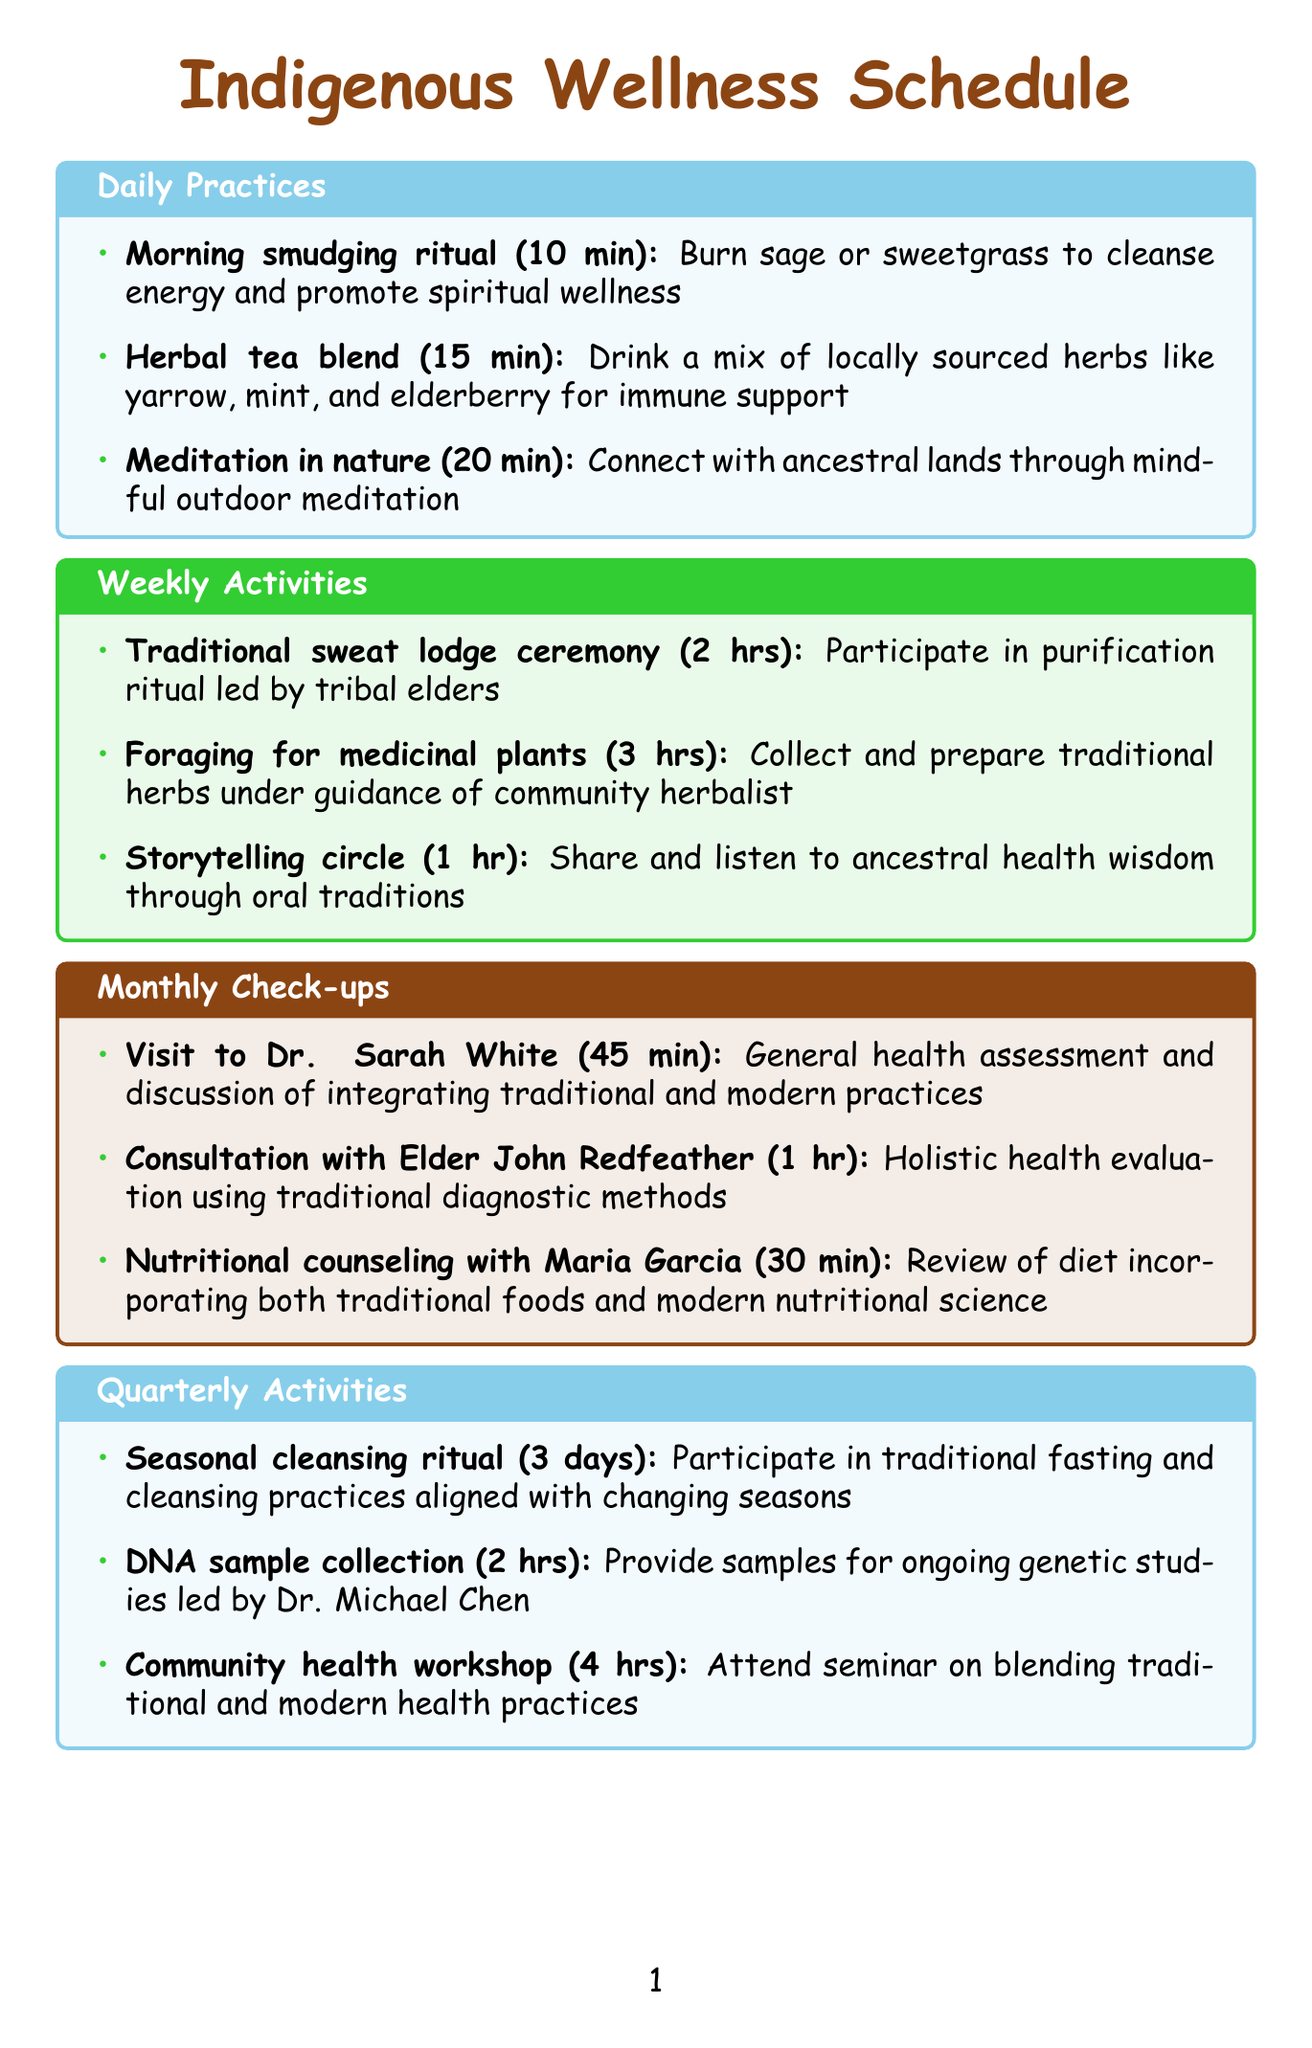What is the duration of the morning smudging ritual? The duration of the morning smudging ritual, as stated in the document, is 10 minutes.
Answer: 10 minutes Who leads the traditional sweat lodge ceremony? The document indicates that the traditional sweat lodge ceremony is led by tribal elders.
Answer: Tribal elders How long is the consultation with Elder John Redfeather? The document specifies that the consultation with Elder John Redfeather lasts for 1 hour.
Answer: 1 hour What is the primary activity during the seasonal cleansing ritual? The document describes the primary activity during the seasonal cleansing ritual as participating in traditional fasting and cleansing practices.
Answer: Traditional fasting and cleansing practices How many hours does the community health workshop last? The document states that the community health workshop lasts for 4 hours.
Answer: 4 hours What is discussed during the visit to Dr. Sarah White? The document mentions that the visit to Dr. Sarah White includes a general health assessment and discussion of integrating traditional and modern practices.
Answer: Discussion of integrating traditional and modern practices How often are comprehensive health screenings conducted? The document highlights that comprehensive health screenings are conducted annually.
Answer: Annually How long is the herbal tea blend practice? The herbal tea blend practice lasts for 15 minutes as per the document.
Answer: 15 minutes What type of activity is the storytelling circle? The document classifies the storytelling circle as a weekly activity where participants share and listen to ancestral health wisdom through oral traditions.
Answer: Weekly activity 